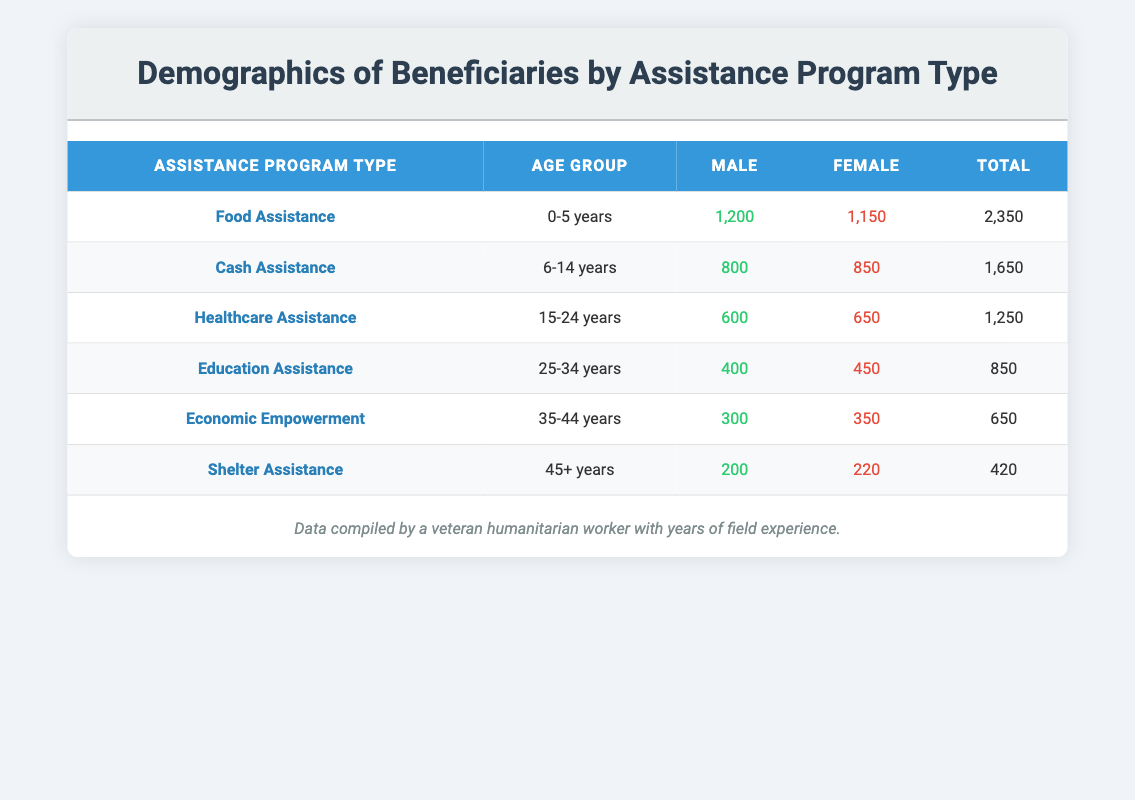What is the total number of beneficiaries receiving Food Assistance? To find the total number of beneficiaries receiving Food Assistance, we look at the row under this program type. The table shows a male count of 1,200 and a female count of 1,150. By adding these two values together (1,200 + 1,150), we get a total of 2,350 beneficiaries for Food Assistance.
Answer: 2,350 Which program type has the highest number of female beneficiaries? We need to compare the female counts across all program types. From the table, the highest female count is found in the Food Assistance program (1,150), followed by Cash Assistance (850), Healthcare Assistance (650), Education Assistance (450), Economic Empowerment (350), and Shelter Assistance (220). Thus, Food Assistance has the highest number of female beneficiaries.
Answer: Food Assistance Is the number of male beneficiaries greater in the 15-24 years age group than in the 35-44 years age group? According to the data, the number of male beneficiaries in the 15-24 years age group (600) is greater than in the 35-44 years age group (300). This means that the statement is true.
Answer: Yes What is the difference in the total number of beneficiaries between Cash Assistance and Education Assistance? We first find the total for each assistance type. Cash Assistance has 800 male and 850 female beneficiaries, summing to 1,650. Education Assistance has 400 male and 450 female beneficiaries, totaling 850. The difference between these totals (1,650 - 850) results in 800 more beneficiaries in Cash Assistance compared to Education Assistance.
Answer: 800 Which gender has a higher total count across all age groups for Shelter Assistance? In the Shelter Assistance program, the male count is 200 and the female count is 220. Comparing these two values, the female beneficiaries (220) are greater than the male beneficiaries (200). Therefore, females have a higher total count in the Shelter Assistance program.
Answer: Female What is the average number of total beneficiaries for the age group 6-14 years? We first identify the number of total beneficiaries for the age group 6-14 years from the Cash Assistance program, which is 800 males and 850 females. The combined total is 1,650. Since there's only one program type for this age group, the average is simply this total (1,650/1) = 1,650.
Answer: 1,650 Does the Healthcare Assistance program have more beneficiaries than the combined totals of Economic Empowerment and Shelter Assistance? For Healthcare Assistance, we have a total of 1,250 (600 male and 650 female). The combined totals of Economic Empowerment (650) and Shelter Assistance (420) equal 1,070. Since 1,250 is greater than 1,070, the Healthcare Assistance program does have more beneficiaries than the combined totals of Economic Empowerment and Shelter Assistance.
Answer: Yes 